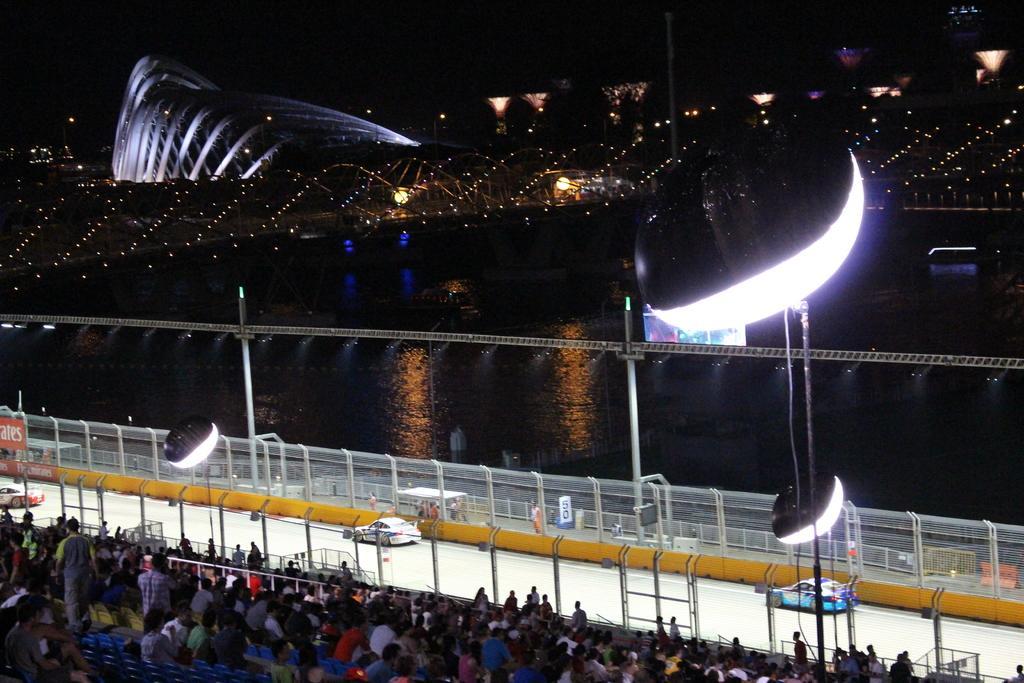Please provide a concise description of this image. This picture might be taken inside a stadium. In this image, in the middle, we can see group of people sitting on chair and few people are walking. In the background, we can see net fence, cars, few people, water in a lake, lights. In the background, we can also see black color. 